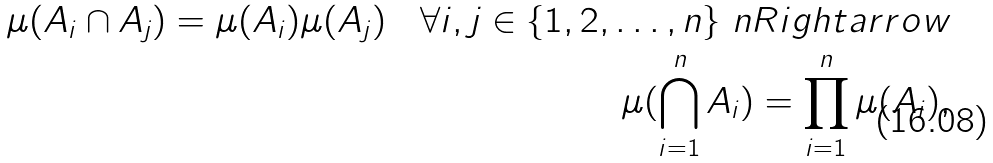<formula> <loc_0><loc_0><loc_500><loc_500>\mu ( A _ { i } \cap A _ { j } ) = \mu ( A _ { i } ) \mu ( A _ { j } ) \quad \forall i , j \in \{ 1 , 2 , \dots , n \} \ n R i g h t a r r o w \\ \mu ( \bigcap _ { i = 1 } ^ { n } A _ { i } ) = \prod _ { i = 1 } ^ { n } \mu ( A _ { i } ) ,</formula> 